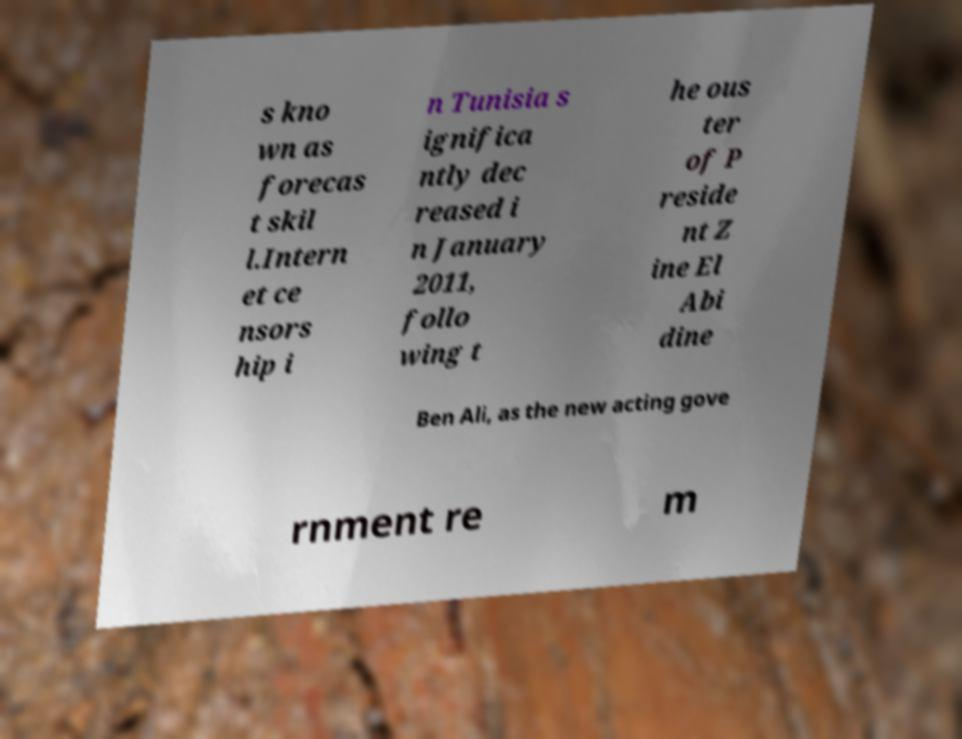What messages or text are displayed in this image? I need them in a readable, typed format. s kno wn as forecas t skil l.Intern et ce nsors hip i n Tunisia s ignifica ntly dec reased i n January 2011, follo wing t he ous ter of P reside nt Z ine El Abi dine Ben Ali, as the new acting gove rnment re m 